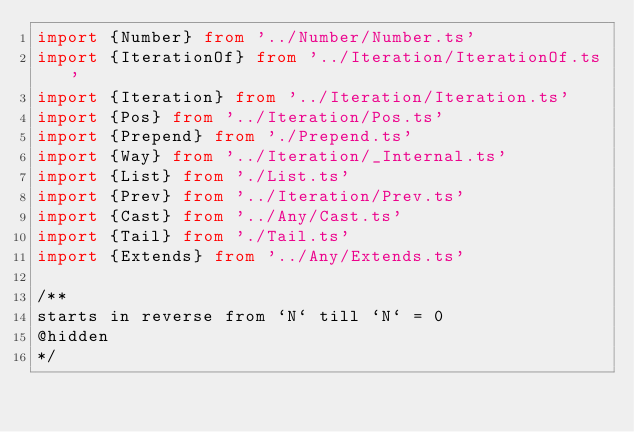Convert code to text. <code><loc_0><loc_0><loc_500><loc_500><_TypeScript_>import {Number} from '../Number/Number.ts'
import {IterationOf} from '../Iteration/IterationOf.ts'
import {Iteration} from '../Iteration/Iteration.ts'
import {Pos} from '../Iteration/Pos.ts'
import {Prepend} from './Prepend.ts'
import {Way} from '../Iteration/_Internal.ts'
import {List} from './List.ts'
import {Prev} from '../Iteration/Prev.ts'
import {Cast} from '../Any/Cast.ts'
import {Tail} from './Tail.ts'
import {Extends} from '../Any/Extends.ts'

/**
starts in reverse from `N` till `N` = 0
@hidden
*/</code> 